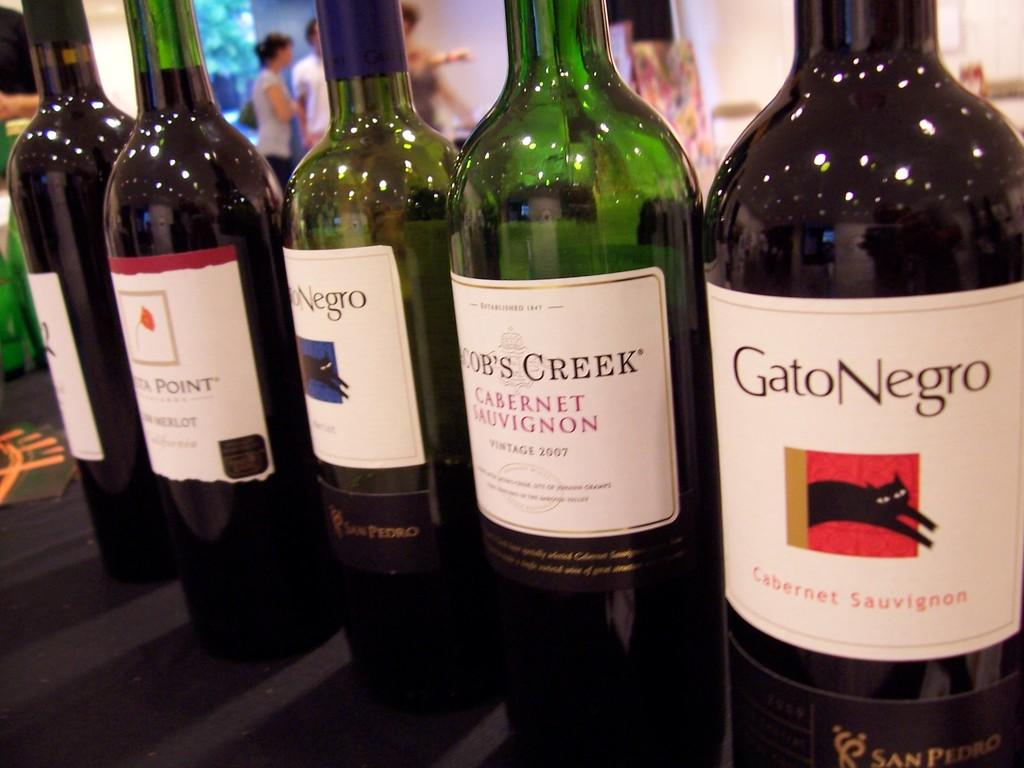<image>
Render a clear and concise summary of the photo. The Cab wine on the far right is named Black Cat in English. 